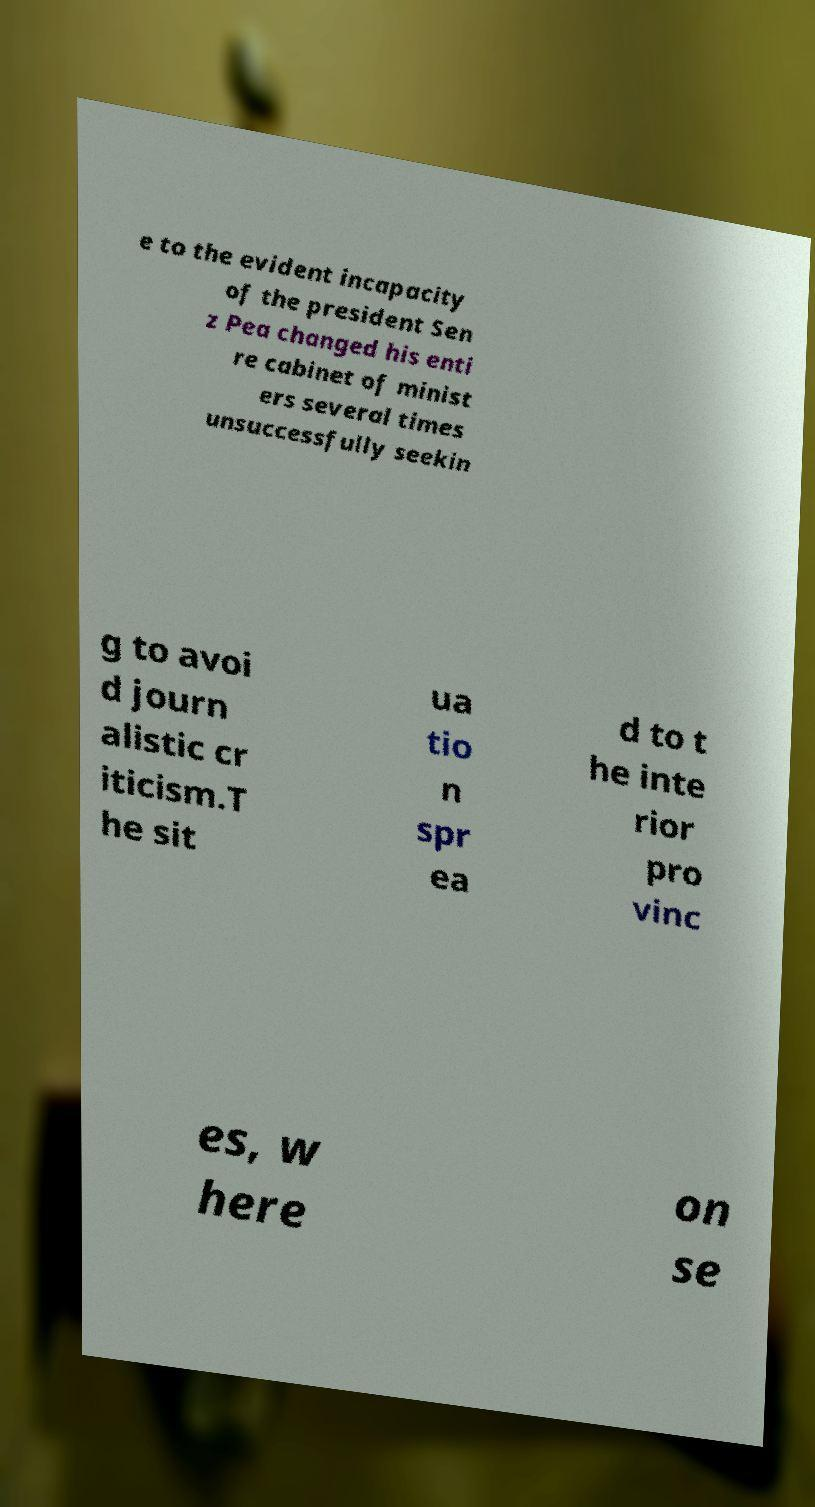Can you accurately transcribe the text from the provided image for me? e to the evident incapacity of the president Sen z Pea changed his enti re cabinet of minist ers several times unsuccessfully seekin g to avoi d journ alistic cr iticism.T he sit ua tio n spr ea d to t he inte rior pro vinc es, w here on se 